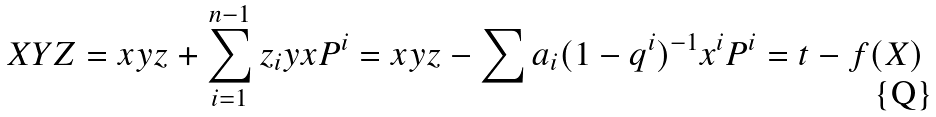Convert formula to latex. <formula><loc_0><loc_0><loc_500><loc_500>X Y Z = x y z + \sum _ { i = 1 } ^ { n - 1 } z _ { i } y x P ^ { i } = x y z - \sum a _ { i } ( 1 - q ^ { i } ) ^ { - 1 } x ^ { i } P ^ { i } = t - f ( X )</formula> 